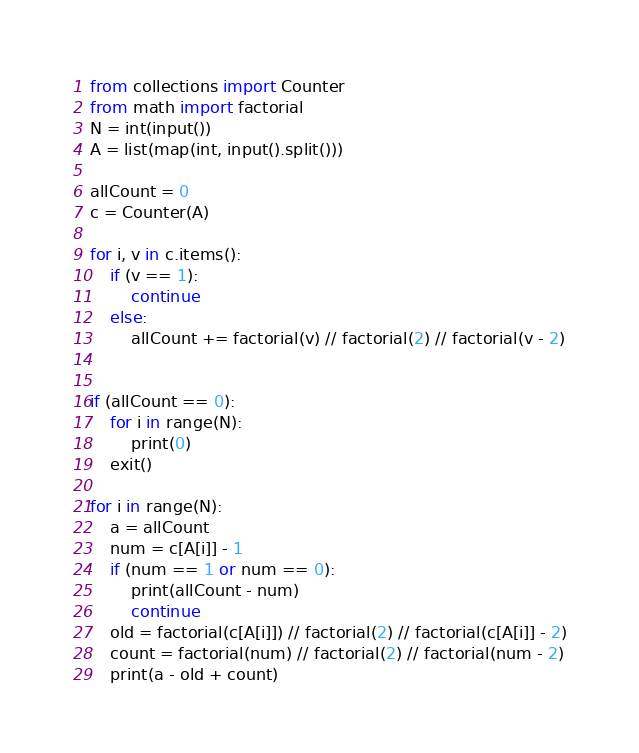Convert code to text. <code><loc_0><loc_0><loc_500><loc_500><_Python_>from collections import Counter
from math import factorial
N = int(input())
A = list(map(int, input().split()))

allCount = 0
c = Counter(A)

for i, v in c.items():
    if (v == 1):
        continue
    else:
        allCount += factorial(v) // factorial(2) // factorial(v - 2)


if (allCount == 0):
    for i in range(N):
        print(0)
    exit()

for i in range(N):
    a = allCount
    num = c[A[i]] - 1
    if (num == 1 or num == 0):
        print(allCount - num)
        continue
    old = factorial(c[A[i]]) // factorial(2) // factorial(c[A[i]] - 2)
    count = factorial(num) // factorial(2) // factorial(num - 2)
    print(a - old + count)
</code> 